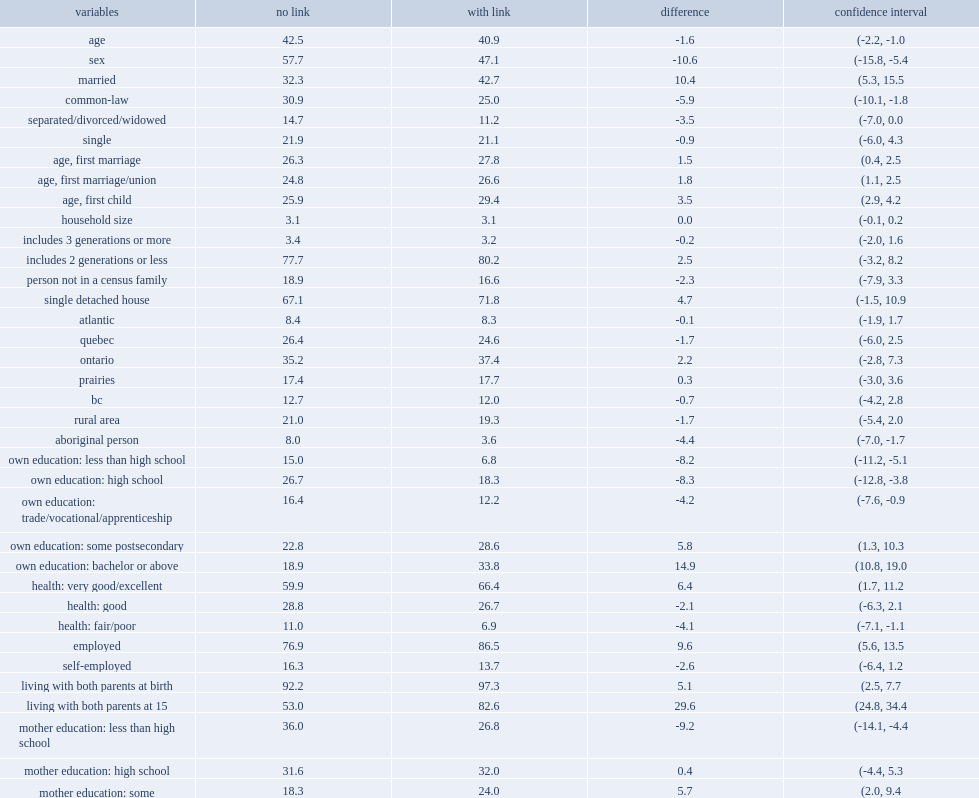Among older individuals, how many percent of people for whom a parental link was established are more likely to be men? 10.6. How many percent of respondents with a parent-child link are more likely to be employed in wave 2? 9.6. How many percent of respondents for whom a parent-child link was found reported very good health? 66.4. How many percent of respondents for who have no parent-child link was found reported very good health? 59.9. How many percent of respondents with a parent-child link are less likely to self-identify as aboriginal? 4.4. How many percent of people with parent-child link are more likely than those without link to be married? 10.4. 